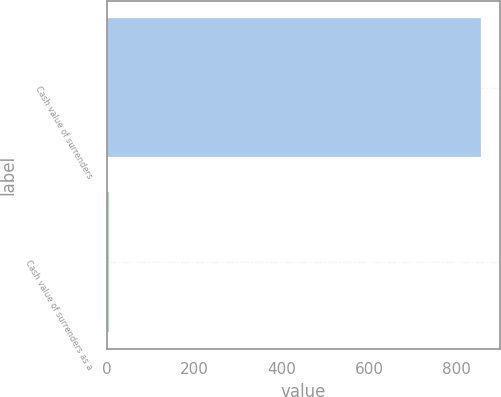Convert chart. <chart><loc_0><loc_0><loc_500><loc_500><bar_chart><fcel>Cash value of surrenders<fcel>Cash value of surrenders as a<nl><fcel>855<fcel>4.2<nl></chart> 